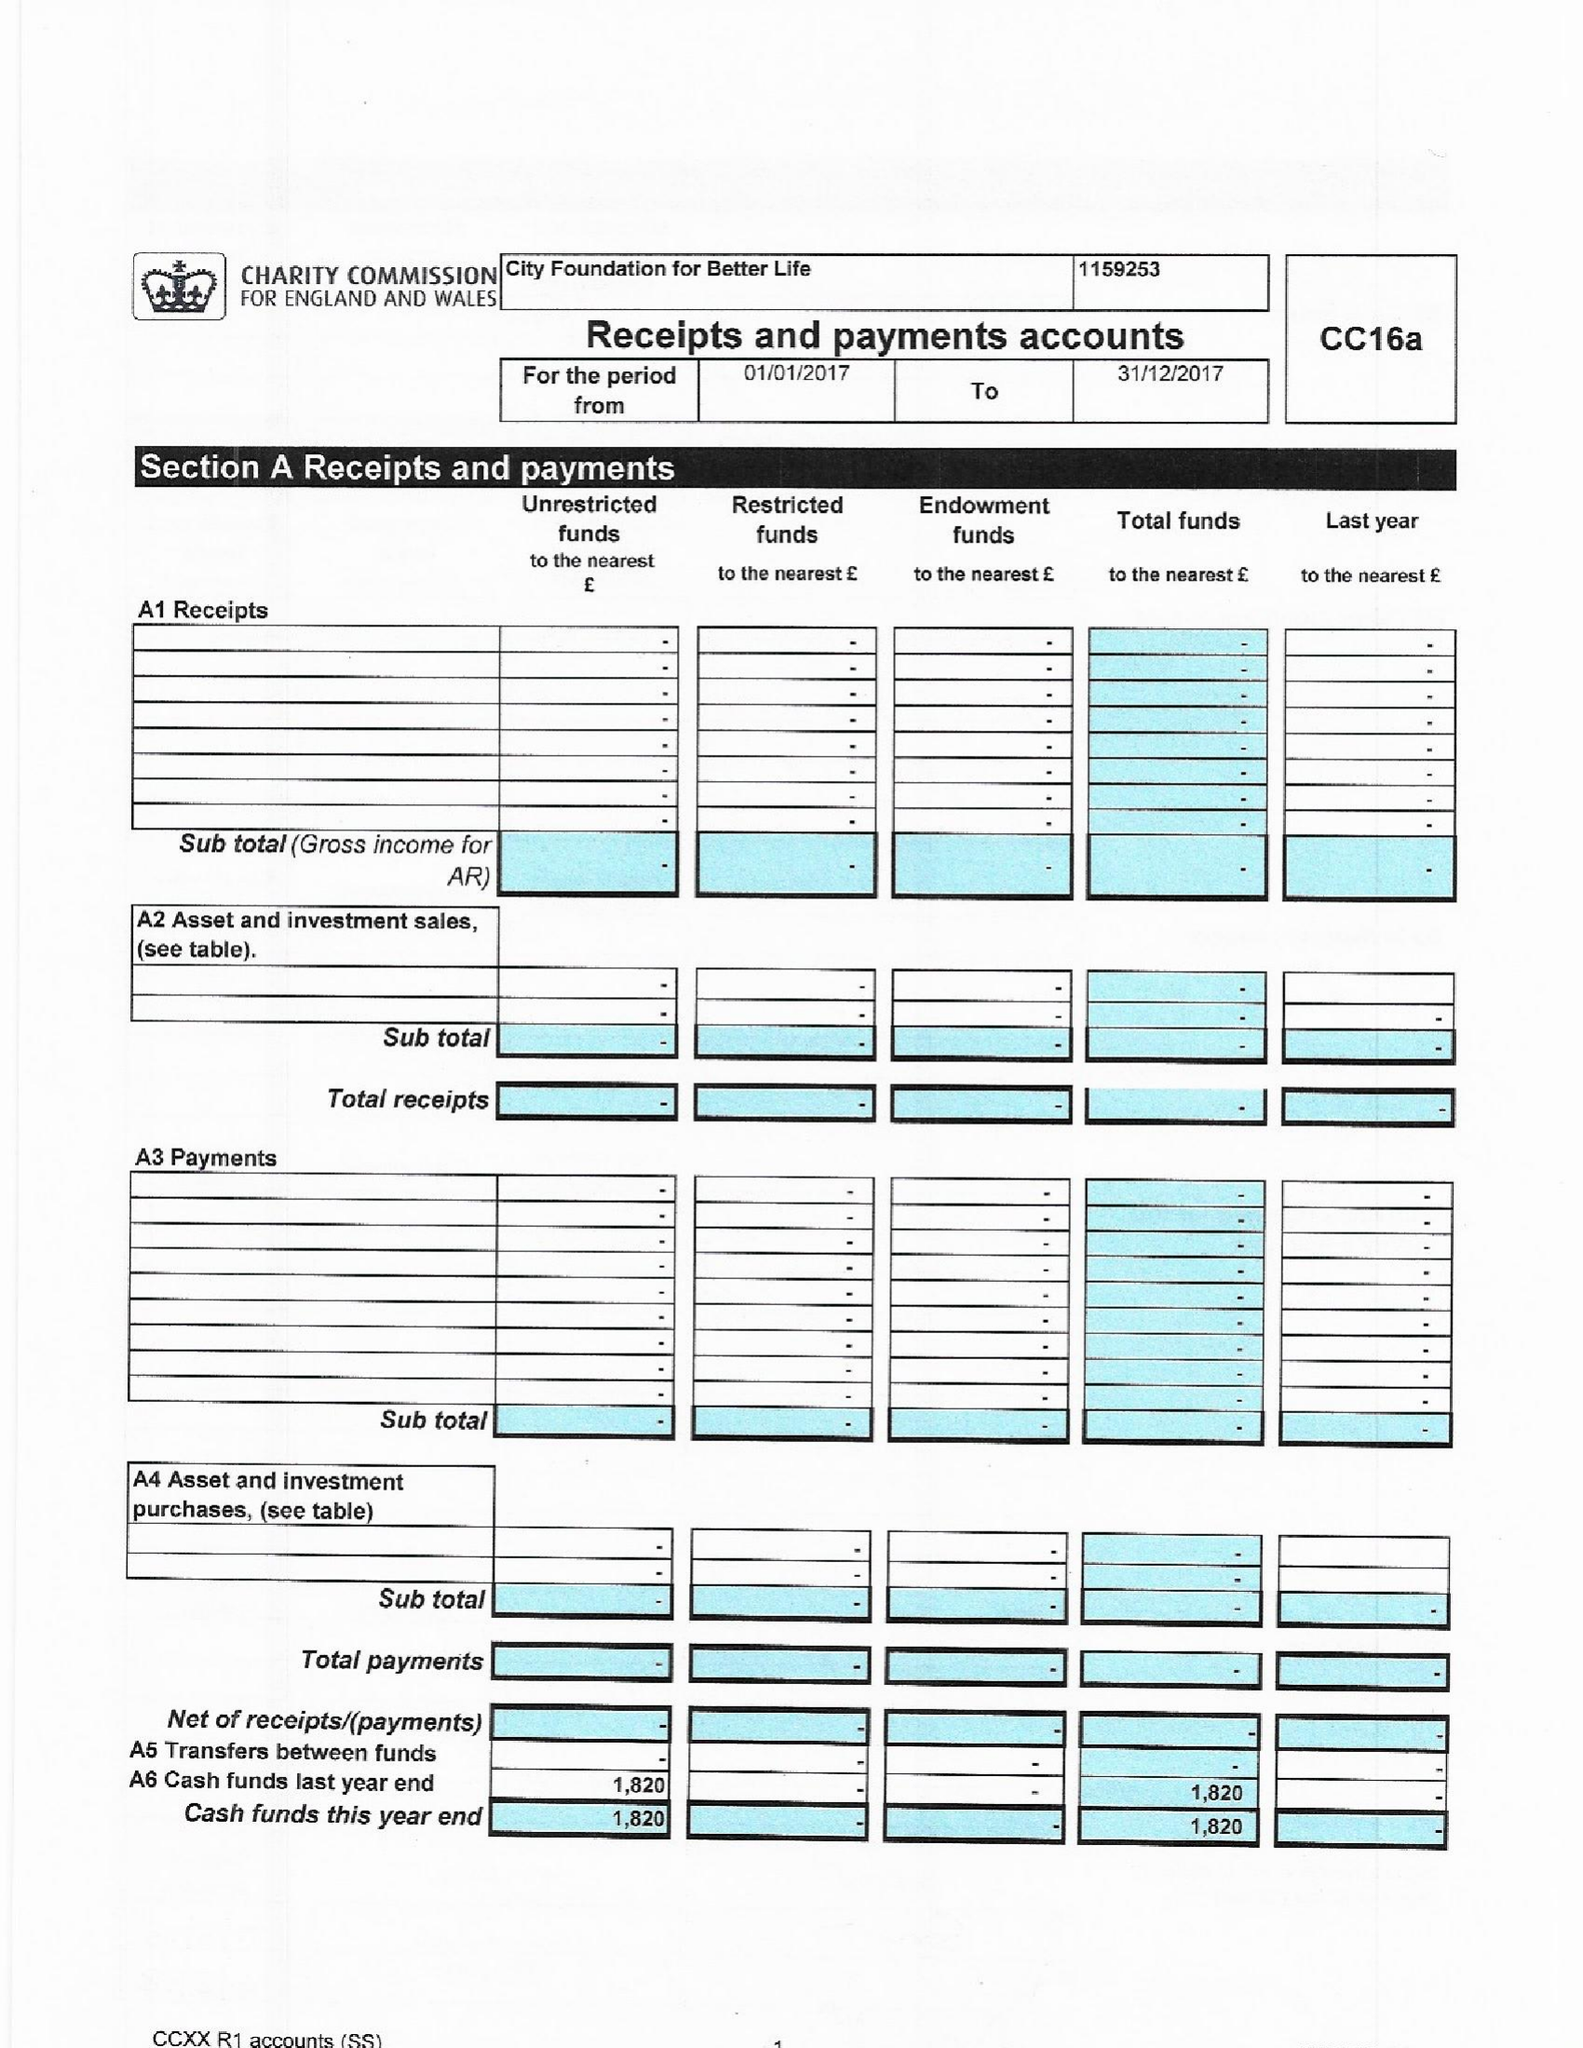What is the value for the charity_number?
Answer the question using a single word or phrase. 1159253 